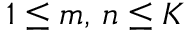<formula> <loc_0><loc_0><loc_500><loc_500>1 \leq m , \, n \leq K</formula> 